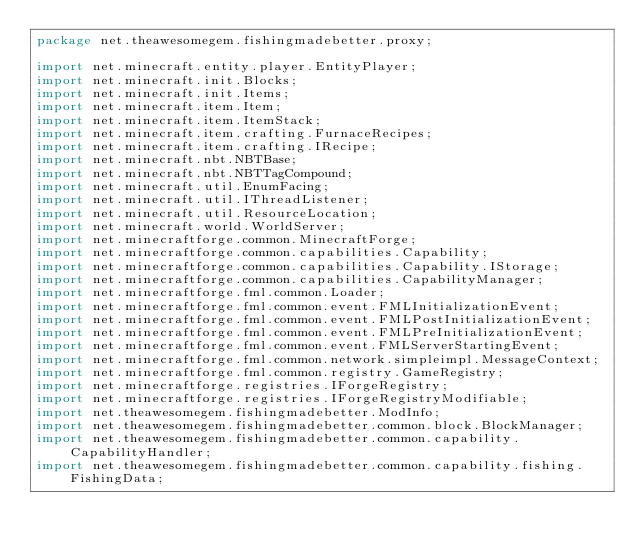<code> <loc_0><loc_0><loc_500><loc_500><_Java_>package net.theawesomegem.fishingmadebetter.proxy;

import net.minecraft.entity.player.EntityPlayer;
import net.minecraft.init.Blocks;
import net.minecraft.init.Items;
import net.minecraft.item.Item;
import net.minecraft.item.ItemStack;
import net.minecraft.item.crafting.FurnaceRecipes;
import net.minecraft.item.crafting.IRecipe;
import net.minecraft.nbt.NBTBase;
import net.minecraft.nbt.NBTTagCompound;
import net.minecraft.util.EnumFacing;
import net.minecraft.util.IThreadListener;
import net.minecraft.util.ResourceLocation;
import net.minecraft.world.WorldServer;
import net.minecraftforge.common.MinecraftForge;
import net.minecraftforge.common.capabilities.Capability;
import net.minecraftforge.common.capabilities.Capability.IStorage;
import net.minecraftforge.common.capabilities.CapabilityManager;
import net.minecraftforge.fml.common.Loader;
import net.minecraftforge.fml.common.event.FMLInitializationEvent;
import net.minecraftforge.fml.common.event.FMLPostInitializationEvent;
import net.minecraftforge.fml.common.event.FMLPreInitializationEvent;
import net.minecraftforge.fml.common.event.FMLServerStartingEvent;
import net.minecraftforge.fml.common.network.simpleimpl.MessageContext;
import net.minecraftforge.fml.common.registry.GameRegistry;
import net.minecraftforge.registries.IForgeRegistry;
import net.minecraftforge.registries.IForgeRegistryModifiable;
import net.theawesomegem.fishingmadebetter.ModInfo;
import net.theawesomegem.fishingmadebetter.common.block.BlockManager;
import net.theawesomegem.fishingmadebetter.common.capability.CapabilityHandler;
import net.theawesomegem.fishingmadebetter.common.capability.fishing.FishingData;</code> 